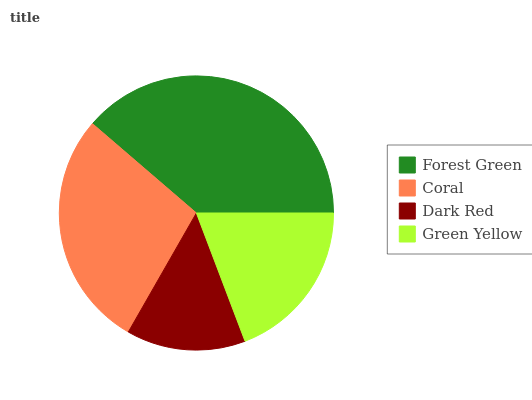Is Dark Red the minimum?
Answer yes or no. Yes. Is Forest Green the maximum?
Answer yes or no. Yes. Is Coral the minimum?
Answer yes or no. No. Is Coral the maximum?
Answer yes or no. No. Is Forest Green greater than Coral?
Answer yes or no. Yes. Is Coral less than Forest Green?
Answer yes or no. Yes. Is Coral greater than Forest Green?
Answer yes or no. No. Is Forest Green less than Coral?
Answer yes or no. No. Is Coral the high median?
Answer yes or no. Yes. Is Green Yellow the low median?
Answer yes or no. Yes. Is Forest Green the high median?
Answer yes or no. No. Is Coral the low median?
Answer yes or no. No. 